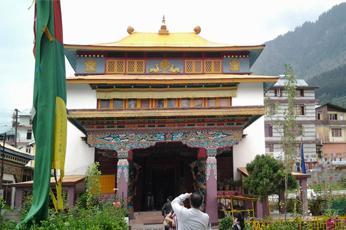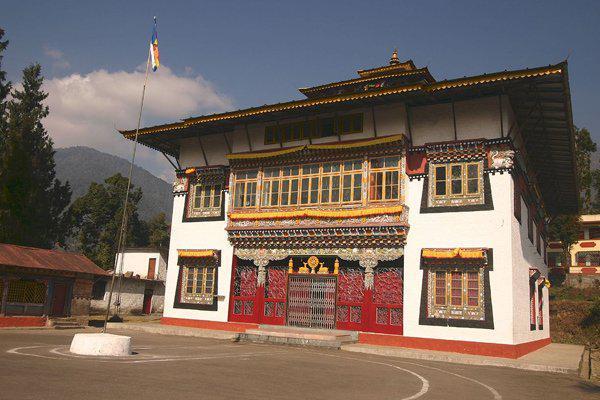The first image is the image on the left, the second image is the image on the right. For the images displayed, is the sentence "Each image shows an ornate building with a series of posts that support a roof hanging over a walkway that allows access to an entrance." factually correct? Answer yes or no. No. The first image is the image on the left, the second image is the image on the right. For the images displayed, is the sentence "There is at least one flag in front the building in at least one of the images." factually correct? Answer yes or no. Yes. 